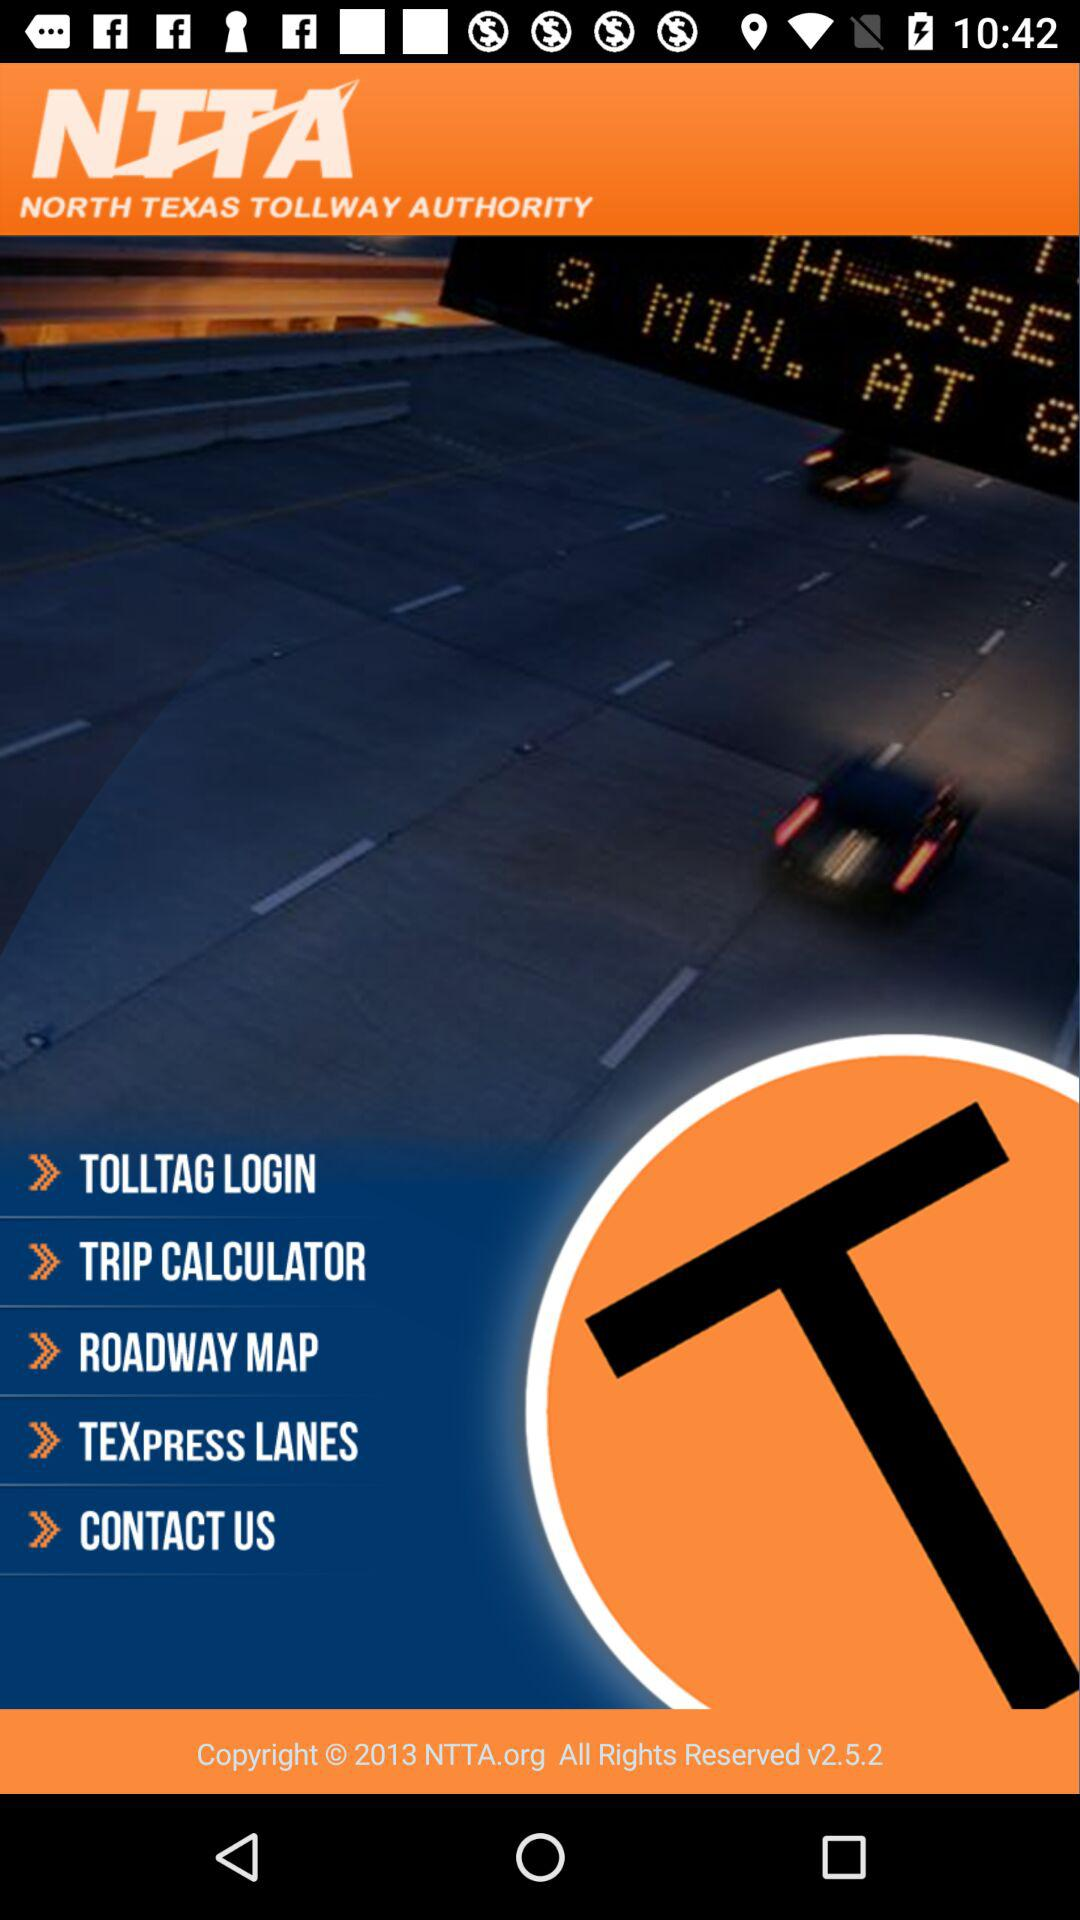Is there a contact number to call for help?
When the provided information is insufficient, respond with <no answer>. <no answer> 